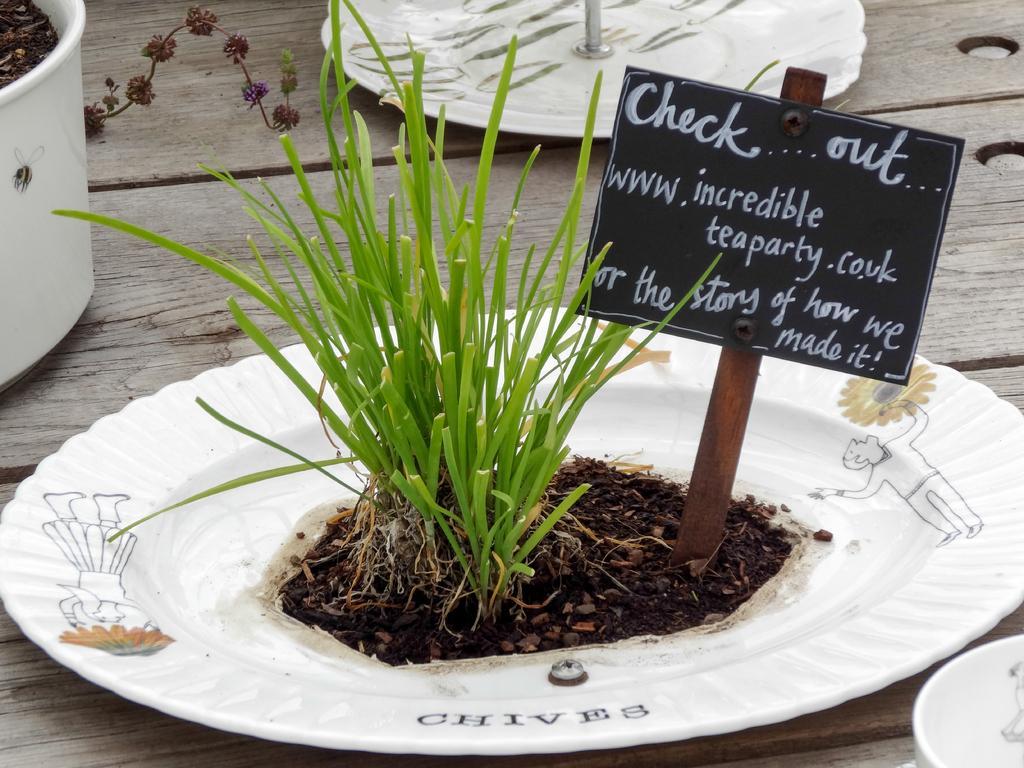Please provide a concise description of this image. In the image we can see plate, white in color and design on the plate. On the plate we can see soil, grass and a small board. Here we can even see white container and a bowl. Here we can see a wooden surface. 